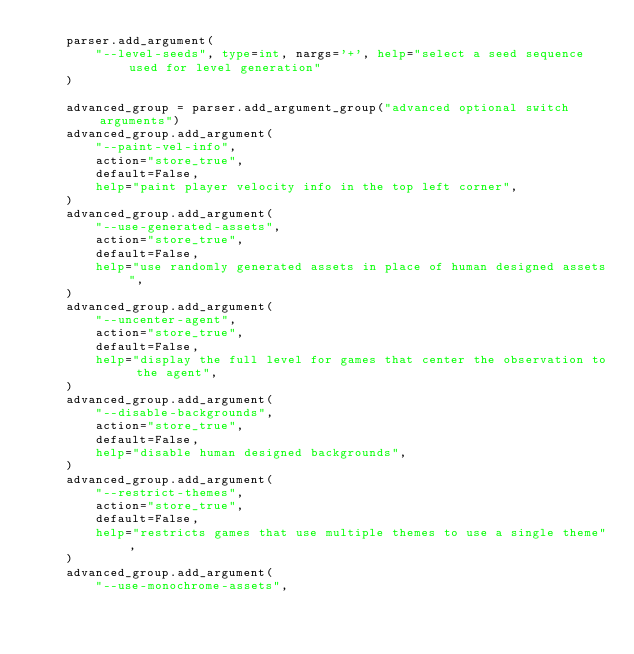<code> <loc_0><loc_0><loc_500><loc_500><_Python_>    parser.add_argument(
        "--level-seeds", type=int, nargs='+', help="select a seed sequence used for level generation"
    )

    advanced_group = parser.add_argument_group("advanced optional switch arguments")
    advanced_group.add_argument(
        "--paint-vel-info",
        action="store_true",
        default=False,
        help="paint player velocity info in the top left corner",
    )
    advanced_group.add_argument(
        "--use-generated-assets",
        action="store_true",
        default=False,
        help="use randomly generated assets in place of human designed assets",
    )
    advanced_group.add_argument(
        "--uncenter-agent",
        action="store_true",
        default=False,
        help="display the full level for games that center the observation to the agent",
    )
    advanced_group.add_argument(
        "--disable-backgrounds",
        action="store_true",
        default=False,
        help="disable human designed backgrounds",
    )
    advanced_group.add_argument(
        "--restrict-themes",
        action="store_true",
        default=False,
        help="restricts games that use multiple themes to use a single theme",
    )
    advanced_group.add_argument(
        "--use-monochrome-assets",</code> 